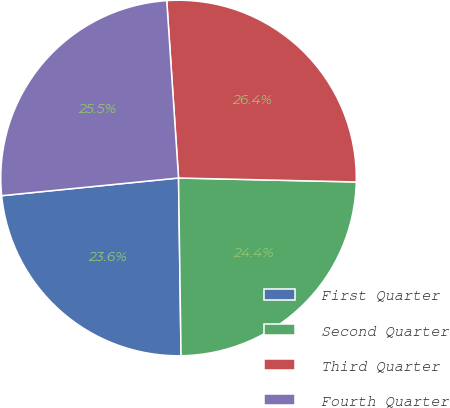Convert chart to OTSL. <chart><loc_0><loc_0><loc_500><loc_500><pie_chart><fcel>First Quarter<fcel>Second Quarter<fcel>Third Quarter<fcel>Fourth Quarter<nl><fcel>23.64%<fcel>24.42%<fcel>26.41%<fcel>25.53%<nl></chart> 